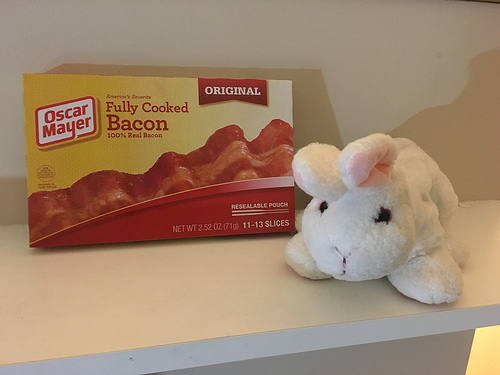<image>
Is there a box in the wall? No. The box is not contained within the wall. These objects have a different spatial relationship. Where is the soft toy in relation to the table? Is it above the table? No. The soft toy is not positioned above the table. The vertical arrangement shows a different relationship. 